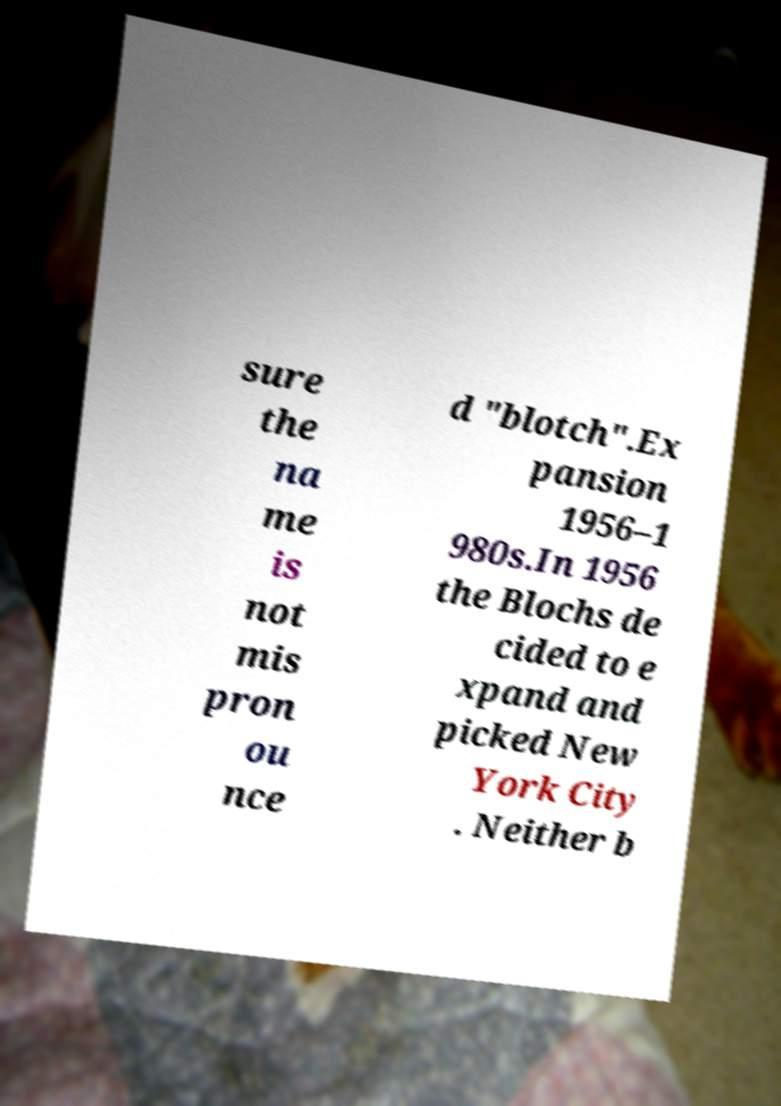Please identify and transcribe the text found in this image. sure the na me is not mis pron ou nce d "blotch".Ex pansion 1956–1 980s.In 1956 the Blochs de cided to e xpand and picked New York City . Neither b 